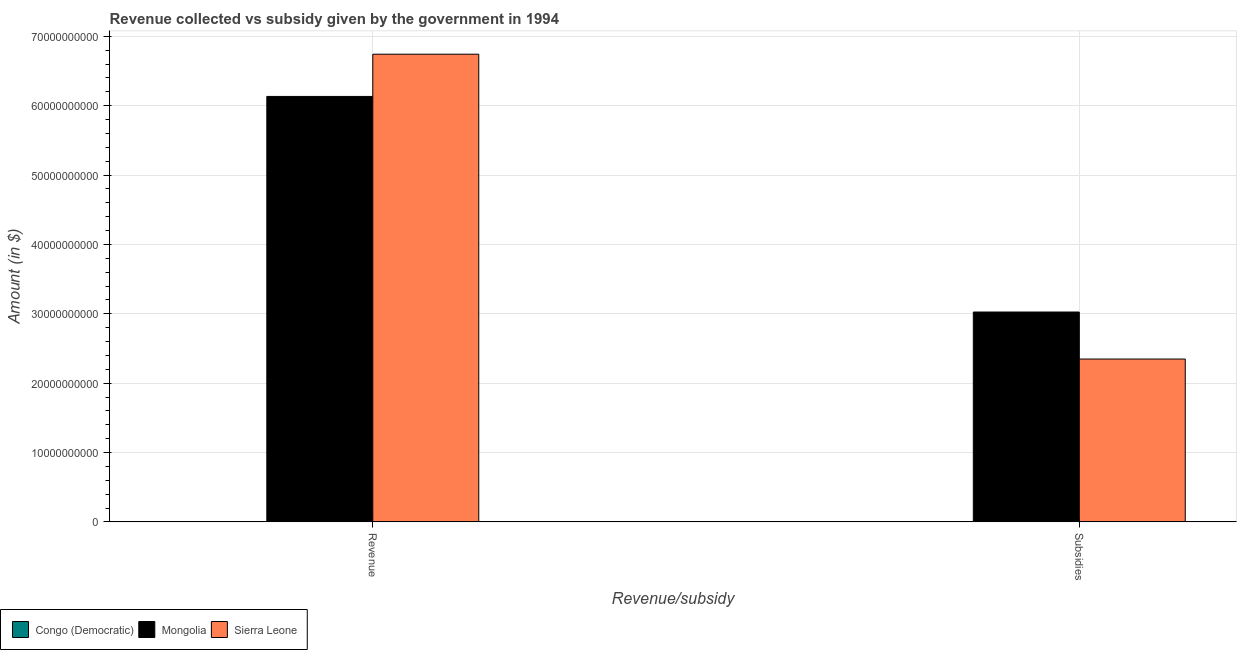Are the number of bars on each tick of the X-axis equal?
Provide a succinct answer. Yes. How many bars are there on the 1st tick from the right?
Provide a succinct answer. 3. What is the label of the 1st group of bars from the left?
Give a very brief answer. Revenue. What is the amount of subsidies given in Sierra Leone?
Make the answer very short. 2.35e+1. Across all countries, what is the maximum amount of revenue collected?
Offer a very short reply. 6.74e+1. Across all countries, what is the minimum amount of subsidies given?
Keep it short and to the point. 3.00e+05. In which country was the amount of subsidies given maximum?
Provide a short and direct response. Mongolia. In which country was the amount of subsidies given minimum?
Your answer should be compact. Congo (Democratic). What is the total amount of subsidies given in the graph?
Your answer should be compact. 5.37e+1. What is the difference between the amount of revenue collected in Mongolia and that in Congo (Democratic)?
Provide a short and direct response. 6.13e+1. What is the difference between the amount of subsidies given in Congo (Democratic) and the amount of revenue collected in Mongolia?
Give a very brief answer. -6.13e+1. What is the average amount of subsidies given per country?
Provide a succinct answer. 1.79e+1. What is the difference between the amount of subsidies given and amount of revenue collected in Congo (Democratic)?
Ensure brevity in your answer.  -1.78e+06. In how many countries, is the amount of revenue collected greater than 18000000000 $?
Keep it short and to the point. 2. What is the ratio of the amount of revenue collected in Mongolia to that in Congo (Democratic)?
Provide a short and direct response. 2.94e+04. Is the amount of subsidies given in Sierra Leone less than that in Congo (Democratic)?
Give a very brief answer. No. What does the 3rd bar from the left in Subsidies represents?
Your answer should be compact. Sierra Leone. What does the 2nd bar from the right in Revenue represents?
Ensure brevity in your answer.  Mongolia. How many bars are there?
Make the answer very short. 6. How many countries are there in the graph?
Keep it short and to the point. 3. What is the difference between two consecutive major ticks on the Y-axis?
Provide a short and direct response. 1.00e+1. Are the values on the major ticks of Y-axis written in scientific E-notation?
Provide a short and direct response. No. Where does the legend appear in the graph?
Give a very brief answer. Bottom left. What is the title of the graph?
Offer a terse response. Revenue collected vs subsidy given by the government in 1994. What is the label or title of the X-axis?
Offer a terse response. Revenue/subsidy. What is the label or title of the Y-axis?
Provide a succinct answer. Amount (in $). What is the Amount (in $) of Congo (Democratic) in Revenue?
Your answer should be very brief. 2.08e+06. What is the Amount (in $) in Mongolia in Revenue?
Your response must be concise. 6.13e+1. What is the Amount (in $) of Sierra Leone in Revenue?
Your answer should be compact. 6.74e+1. What is the Amount (in $) in Mongolia in Subsidies?
Provide a succinct answer. 3.03e+1. What is the Amount (in $) in Sierra Leone in Subsidies?
Provide a short and direct response. 2.35e+1. Across all Revenue/subsidy, what is the maximum Amount (in $) of Congo (Democratic)?
Offer a very short reply. 2.08e+06. Across all Revenue/subsidy, what is the maximum Amount (in $) in Mongolia?
Ensure brevity in your answer.  6.13e+1. Across all Revenue/subsidy, what is the maximum Amount (in $) of Sierra Leone?
Offer a very short reply. 6.74e+1. Across all Revenue/subsidy, what is the minimum Amount (in $) in Mongolia?
Provide a succinct answer. 3.03e+1. Across all Revenue/subsidy, what is the minimum Amount (in $) of Sierra Leone?
Provide a succinct answer. 2.35e+1. What is the total Amount (in $) in Congo (Democratic) in the graph?
Offer a terse response. 2.38e+06. What is the total Amount (in $) in Mongolia in the graph?
Provide a short and direct response. 9.16e+1. What is the total Amount (in $) in Sierra Leone in the graph?
Your answer should be compact. 9.09e+1. What is the difference between the Amount (in $) in Congo (Democratic) in Revenue and that in Subsidies?
Offer a very short reply. 1.78e+06. What is the difference between the Amount (in $) of Mongolia in Revenue and that in Subsidies?
Offer a terse response. 3.11e+1. What is the difference between the Amount (in $) in Sierra Leone in Revenue and that in Subsidies?
Your answer should be very brief. 4.39e+1. What is the difference between the Amount (in $) of Congo (Democratic) in Revenue and the Amount (in $) of Mongolia in Subsidies?
Offer a terse response. -3.02e+1. What is the difference between the Amount (in $) in Congo (Democratic) in Revenue and the Amount (in $) in Sierra Leone in Subsidies?
Ensure brevity in your answer.  -2.35e+1. What is the difference between the Amount (in $) in Mongolia in Revenue and the Amount (in $) in Sierra Leone in Subsidies?
Offer a very short reply. 3.79e+1. What is the average Amount (in $) in Congo (Democratic) per Revenue/subsidy?
Give a very brief answer. 1.19e+06. What is the average Amount (in $) of Mongolia per Revenue/subsidy?
Give a very brief answer. 4.58e+1. What is the average Amount (in $) in Sierra Leone per Revenue/subsidy?
Make the answer very short. 4.54e+1. What is the difference between the Amount (in $) in Congo (Democratic) and Amount (in $) in Mongolia in Revenue?
Your answer should be very brief. -6.13e+1. What is the difference between the Amount (in $) in Congo (Democratic) and Amount (in $) in Sierra Leone in Revenue?
Provide a succinct answer. -6.74e+1. What is the difference between the Amount (in $) in Mongolia and Amount (in $) in Sierra Leone in Revenue?
Keep it short and to the point. -6.08e+09. What is the difference between the Amount (in $) of Congo (Democratic) and Amount (in $) of Mongolia in Subsidies?
Give a very brief answer. -3.03e+1. What is the difference between the Amount (in $) in Congo (Democratic) and Amount (in $) in Sierra Leone in Subsidies?
Provide a succinct answer. -2.35e+1. What is the difference between the Amount (in $) of Mongolia and Amount (in $) of Sierra Leone in Subsidies?
Offer a very short reply. 6.78e+09. What is the ratio of the Amount (in $) of Congo (Democratic) in Revenue to that in Subsidies?
Offer a very short reply. 6.95. What is the ratio of the Amount (in $) of Mongolia in Revenue to that in Subsidies?
Offer a very short reply. 2.03. What is the ratio of the Amount (in $) in Sierra Leone in Revenue to that in Subsidies?
Give a very brief answer. 2.87. What is the difference between the highest and the second highest Amount (in $) of Congo (Democratic)?
Give a very brief answer. 1.78e+06. What is the difference between the highest and the second highest Amount (in $) in Mongolia?
Your answer should be compact. 3.11e+1. What is the difference between the highest and the second highest Amount (in $) in Sierra Leone?
Offer a very short reply. 4.39e+1. What is the difference between the highest and the lowest Amount (in $) of Congo (Democratic)?
Provide a short and direct response. 1.78e+06. What is the difference between the highest and the lowest Amount (in $) of Mongolia?
Your response must be concise. 3.11e+1. What is the difference between the highest and the lowest Amount (in $) in Sierra Leone?
Your answer should be compact. 4.39e+1. 